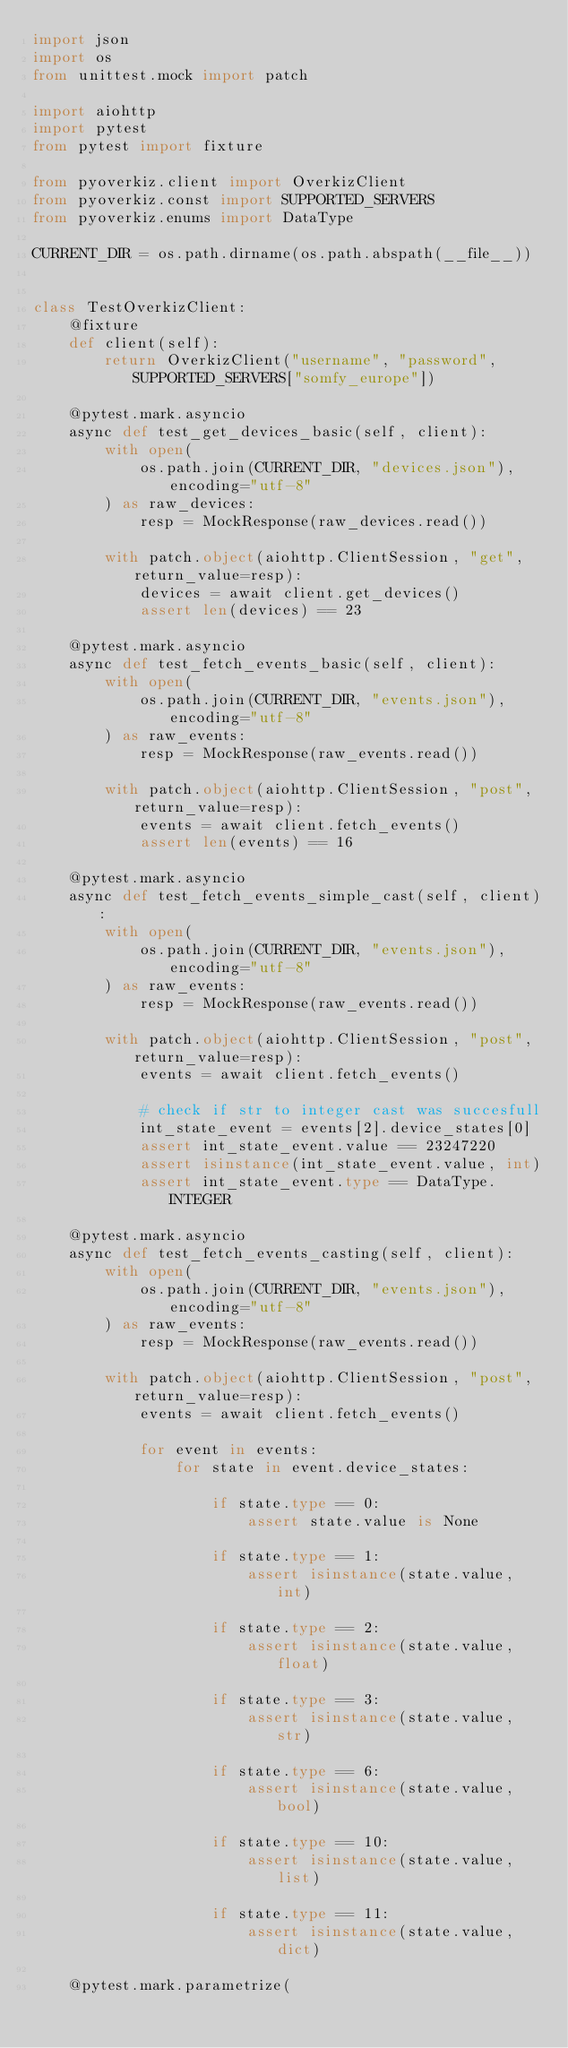<code> <loc_0><loc_0><loc_500><loc_500><_Python_>import json
import os
from unittest.mock import patch

import aiohttp
import pytest
from pytest import fixture

from pyoverkiz.client import OverkizClient
from pyoverkiz.const import SUPPORTED_SERVERS
from pyoverkiz.enums import DataType

CURRENT_DIR = os.path.dirname(os.path.abspath(__file__))


class TestOverkizClient:
    @fixture
    def client(self):
        return OverkizClient("username", "password", SUPPORTED_SERVERS["somfy_europe"])

    @pytest.mark.asyncio
    async def test_get_devices_basic(self, client):
        with open(
            os.path.join(CURRENT_DIR, "devices.json"), encoding="utf-8"
        ) as raw_devices:
            resp = MockResponse(raw_devices.read())

        with patch.object(aiohttp.ClientSession, "get", return_value=resp):
            devices = await client.get_devices()
            assert len(devices) == 23

    @pytest.mark.asyncio
    async def test_fetch_events_basic(self, client):
        with open(
            os.path.join(CURRENT_DIR, "events.json"), encoding="utf-8"
        ) as raw_events:
            resp = MockResponse(raw_events.read())

        with patch.object(aiohttp.ClientSession, "post", return_value=resp):
            events = await client.fetch_events()
            assert len(events) == 16

    @pytest.mark.asyncio
    async def test_fetch_events_simple_cast(self, client):
        with open(
            os.path.join(CURRENT_DIR, "events.json"), encoding="utf-8"
        ) as raw_events:
            resp = MockResponse(raw_events.read())

        with patch.object(aiohttp.ClientSession, "post", return_value=resp):
            events = await client.fetch_events()

            # check if str to integer cast was succesfull
            int_state_event = events[2].device_states[0]
            assert int_state_event.value == 23247220
            assert isinstance(int_state_event.value, int)
            assert int_state_event.type == DataType.INTEGER

    @pytest.mark.asyncio
    async def test_fetch_events_casting(self, client):
        with open(
            os.path.join(CURRENT_DIR, "events.json"), encoding="utf-8"
        ) as raw_events:
            resp = MockResponse(raw_events.read())

        with patch.object(aiohttp.ClientSession, "post", return_value=resp):
            events = await client.fetch_events()

            for event in events:
                for state in event.device_states:

                    if state.type == 0:
                        assert state.value is None

                    if state.type == 1:
                        assert isinstance(state.value, int)

                    if state.type == 2:
                        assert isinstance(state.value, float)

                    if state.type == 3:
                        assert isinstance(state.value, str)

                    if state.type == 6:
                        assert isinstance(state.value, bool)

                    if state.type == 10:
                        assert isinstance(state.value, list)

                    if state.type == 11:
                        assert isinstance(state.value, dict)

    @pytest.mark.parametrize(</code> 